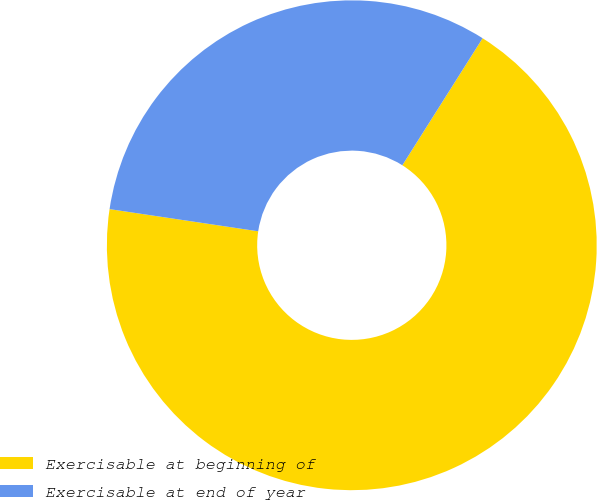Convert chart to OTSL. <chart><loc_0><loc_0><loc_500><loc_500><pie_chart><fcel>Exercisable at beginning of<fcel>Exercisable at end of year<nl><fcel>68.39%<fcel>31.61%<nl></chart> 